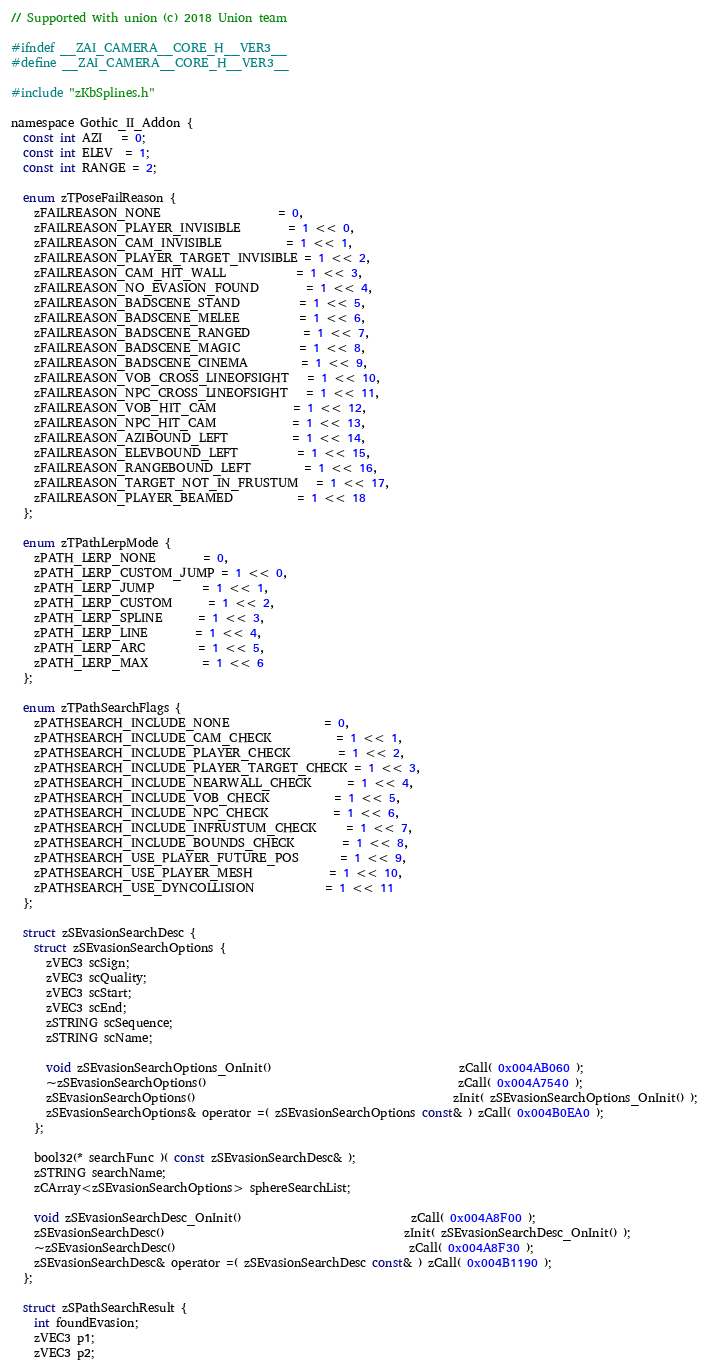<code> <loc_0><loc_0><loc_500><loc_500><_C_>// Supported with union (c) 2018 Union team

#ifndef __ZAI_CAMERA__CORE_H__VER3__
#define __ZAI_CAMERA__CORE_H__VER3__

#include "zKbSplines.h"

namespace Gothic_II_Addon {
  const int AZI   = 0;
  const int ELEV  = 1;
  const int RANGE = 2;

  enum zTPoseFailReason {
    zFAILREASON_NONE                    = 0,
    zFAILREASON_PLAYER_INVISIBLE        = 1 << 0,
    zFAILREASON_CAM_INVISIBLE           = 1 << 1,
    zFAILREASON_PLAYER_TARGET_INVISIBLE = 1 << 2,
    zFAILREASON_CAM_HIT_WALL            = 1 << 3,
    zFAILREASON_NO_EVASION_FOUND        = 1 << 4,
    zFAILREASON_BADSCENE_STAND          = 1 << 5,
    zFAILREASON_BADSCENE_MELEE          = 1 << 6,
    zFAILREASON_BADSCENE_RANGED         = 1 << 7,
    zFAILREASON_BADSCENE_MAGIC          = 1 << 8,
    zFAILREASON_BADSCENE_CINEMA         = 1 << 9,
    zFAILREASON_VOB_CROSS_LINEOFSIGHT   = 1 << 10,
    zFAILREASON_NPC_CROSS_LINEOFSIGHT   = 1 << 11,
    zFAILREASON_VOB_HIT_CAM             = 1 << 12,
    zFAILREASON_NPC_HIT_CAM             = 1 << 13,
    zFAILREASON_AZIBOUND_LEFT           = 1 << 14,
    zFAILREASON_ELEVBOUND_LEFT          = 1 << 15,
    zFAILREASON_RANGEBOUND_LEFT         = 1 << 16,
    zFAILREASON_TARGET_NOT_IN_FRUSTUM   = 1 << 17,
    zFAILREASON_PLAYER_BEAMED           = 1 << 18
  };

  enum zTPathLerpMode {
    zPATH_LERP_NONE        = 0,
    zPATH_LERP_CUSTOM_JUMP = 1 << 0,
    zPATH_LERP_JUMP        = 1 << 1,
    zPATH_LERP_CUSTOM      = 1 << 2,
    zPATH_LERP_SPLINE      = 1 << 3,
    zPATH_LERP_LINE        = 1 << 4,
    zPATH_LERP_ARC         = 1 << 5,
    zPATH_LERP_MAX         = 1 << 6
  };

  enum zTPathSearchFlags {
    zPATHSEARCH_INCLUDE_NONE                = 0,
    zPATHSEARCH_INCLUDE_CAM_CHECK           = 1 << 1,
    zPATHSEARCH_INCLUDE_PLAYER_CHECK        = 1 << 2,
    zPATHSEARCH_INCLUDE_PLAYER_TARGET_CHECK = 1 << 3,
    zPATHSEARCH_INCLUDE_NEARWALL_CHECK      = 1 << 4,
    zPATHSEARCH_INCLUDE_VOB_CHECK           = 1 << 5,
    zPATHSEARCH_INCLUDE_NPC_CHECK           = 1 << 6,
    zPATHSEARCH_INCLUDE_INFRUSTUM_CHECK     = 1 << 7,
    zPATHSEARCH_INCLUDE_BOUNDS_CHECK        = 1 << 8,
    zPATHSEARCH_USE_PLAYER_FUTURE_POS       = 1 << 9,
    zPATHSEARCH_USE_PLAYER_MESH             = 1 << 10,
    zPATHSEARCH_USE_DYNCOLLISION            = 1 << 11
  };

  struct zSEvasionSearchDesc {
    struct zSEvasionSearchOptions {
      zVEC3 scSign;
      zVEC3 scQuality;
      zVEC3 scStart;
      zVEC3 scEnd;
      zSTRING scSequence;
      zSTRING scName;

      void zSEvasionSearchOptions_OnInit()                                zCall( 0x004AB060 );
      ~zSEvasionSearchOptions()                                           zCall( 0x004A7540 );
      zSEvasionSearchOptions()                                            zInit( zSEvasionSearchOptions_OnInit() );
      zSEvasionSearchOptions& operator =( zSEvasionSearchOptions const& ) zCall( 0x004B0EA0 );
    };

    bool32(* searchFunc )( const zSEvasionSearchDesc& );
    zSTRING searchName;
    zCArray<zSEvasionSearchOptions> sphereSearchList;

    void zSEvasionSearchDesc_OnInit()                             zCall( 0x004A8F00 );
    zSEvasionSearchDesc()                                         zInit( zSEvasionSearchDesc_OnInit() );
    ~zSEvasionSearchDesc()                                        zCall( 0x004A8F30 );
    zSEvasionSearchDesc& operator =( zSEvasionSearchDesc const& ) zCall( 0x004B1190 );
  };

  struct zSPathSearchResult {
    int foundEvasion;
    zVEC3 p1;
    zVEC3 p2;</code> 